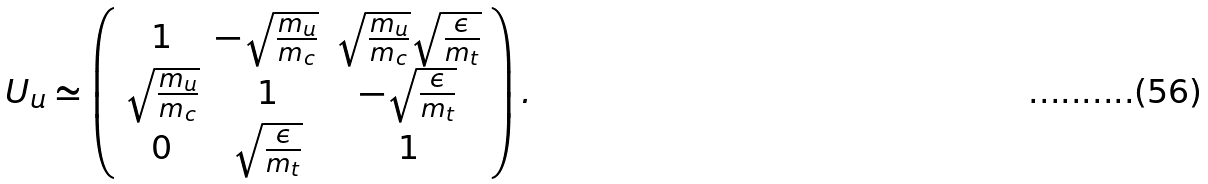<formula> <loc_0><loc_0><loc_500><loc_500>U _ { u } \simeq \left ( \begin{array} { c c c } 1 & - \sqrt { \frac { m _ { u } } { m _ { c } } } & \sqrt { \frac { m _ { u } } { m _ { c } } } \sqrt { \frac { \epsilon } { m _ { t } } } \\ \sqrt { \frac { m _ { u } } { m _ { c } } } & 1 & - \sqrt { \frac { \epsilon } { m _ { t } } } \\ 0 & \sqrt { \frac { \epsilon } { m _ { t } } } & 1 \end{array} \right ) .</formula> 